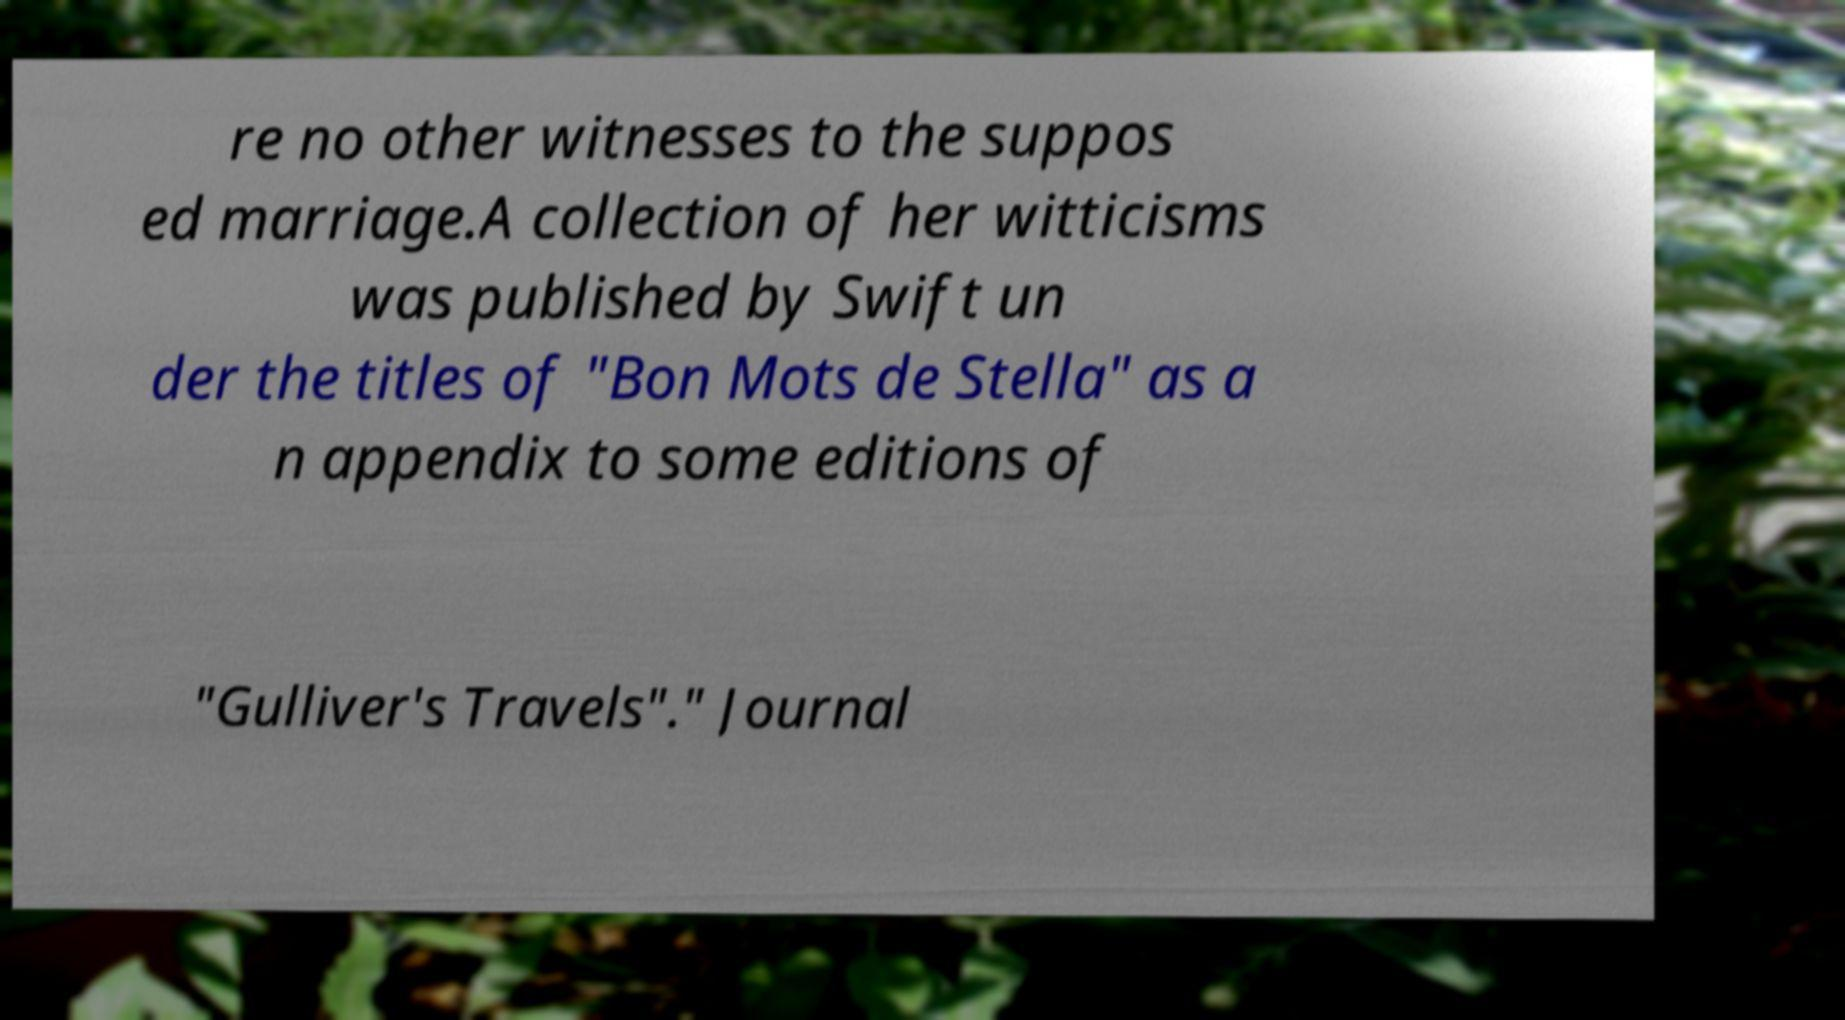I need the written content from this picture converted into text. Can you do that? re no other witnesses to the suppos ed marriage.A collection of her witticisms was published by Swift un der the titles of "Bon Mots de Stella" as a n appendix to some editions of "Gulliver's Travels"." Journal 